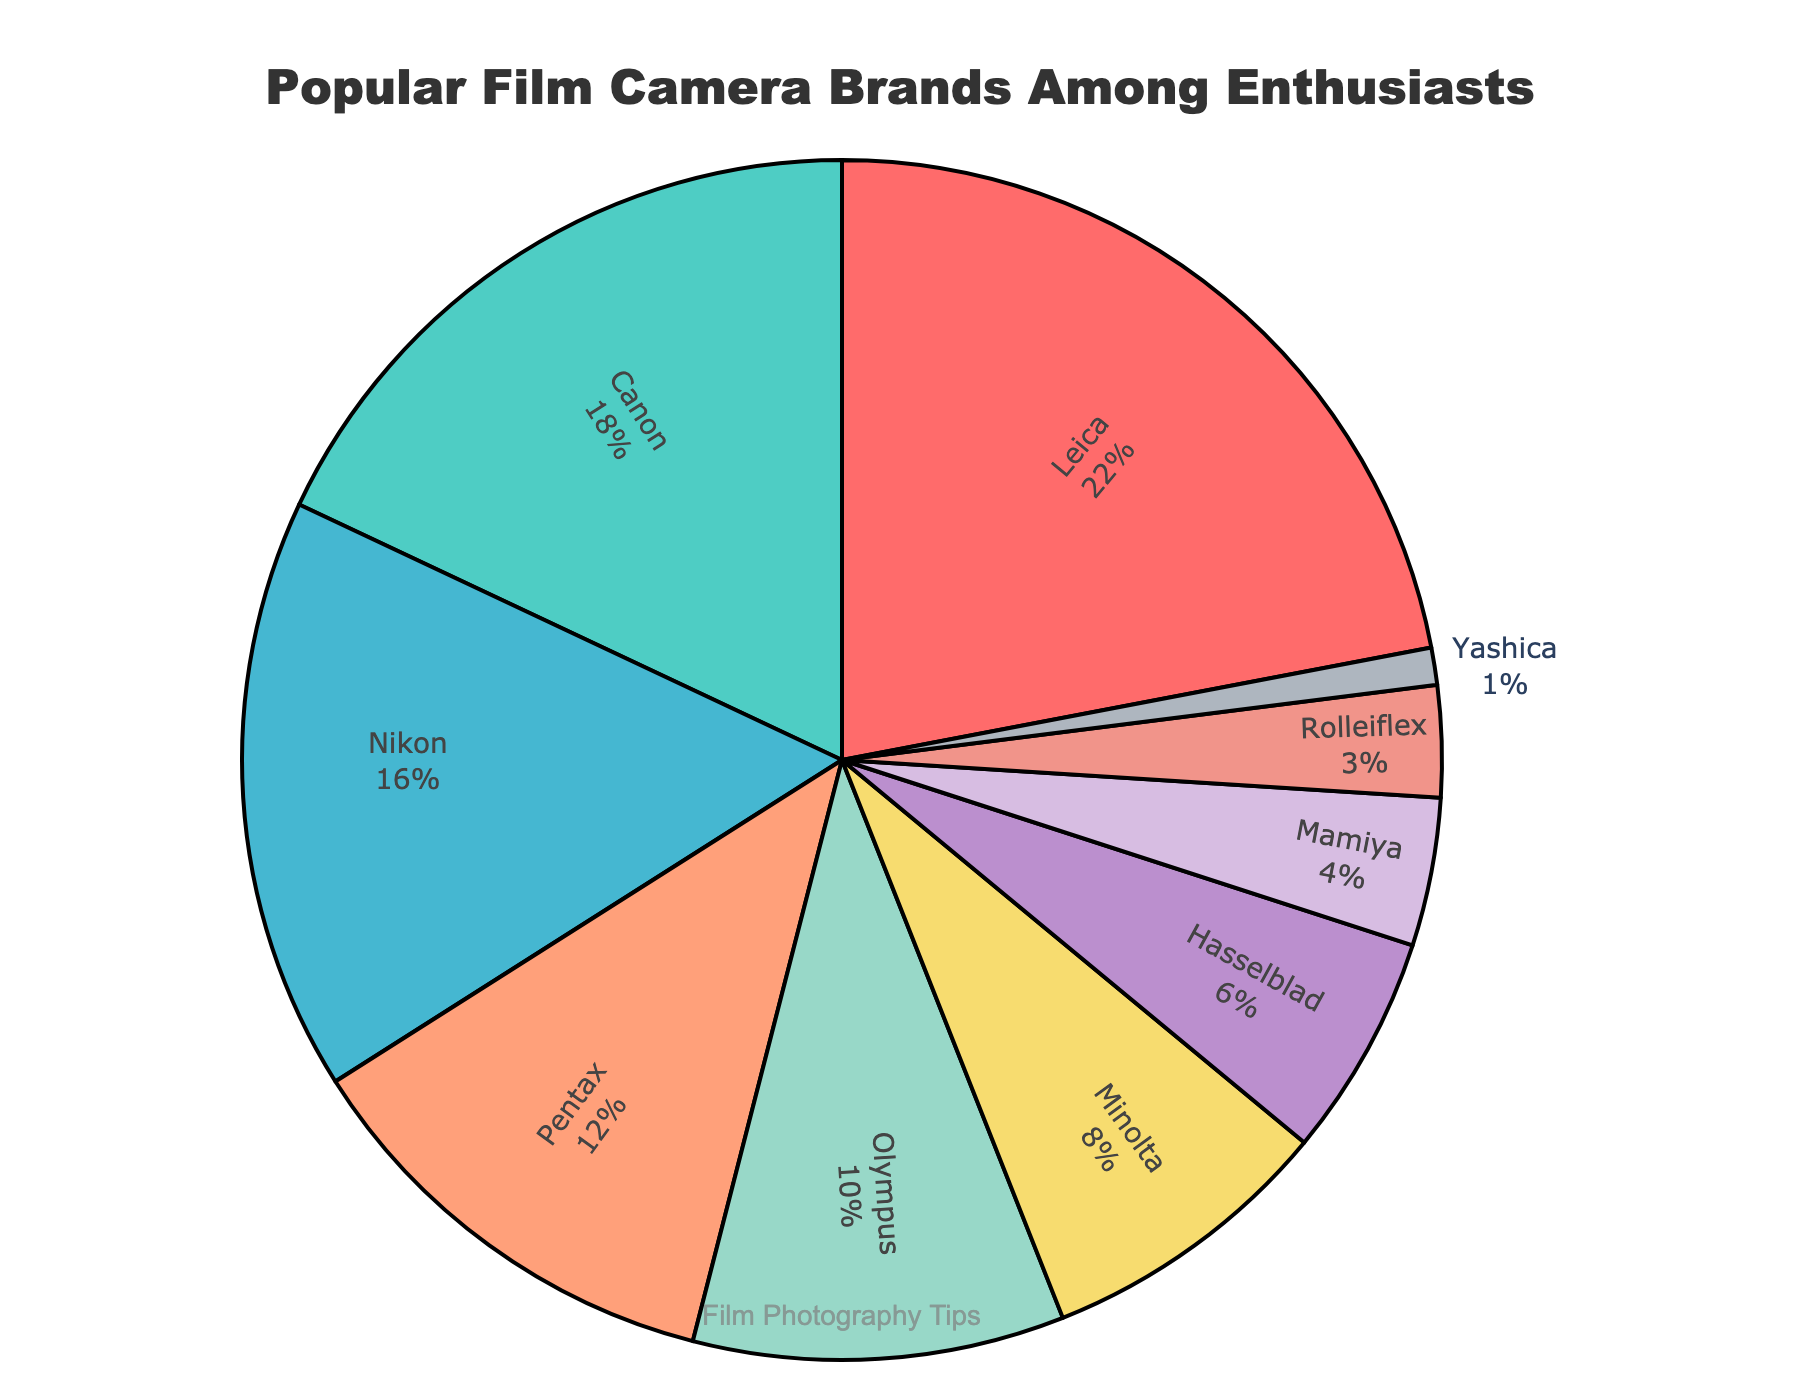Which brand has the highest percentage among film camera enthusiasts? The figure shows various brands with their respective percentage values. Leica has the highest percentage of 22%.
Answer: Leica Which brand has the lowest percentage among film camera enthusiasts? The figure displays all the brands with their percentages. Yashica has the lowest at 1%.
Answer: Yashica What is the combined percentage of Canon and Nikon enthusiasts? Canon has 18% and Nikon has 16%. Adding these together: 18% + 16% = 34%.
Answer: 34% How does the percentage of Olympus compare to that of Pentax? The figure shows Olympus at 10% and Pentax at 12%. Olympus's percentage is 2% less than Pentax's.
Answer: 2% less What is the total percentage of the four least popular brands? The four least popular brands are Rolleiflex (3%), Mamiya (4%), Hasselblad (6%), and Yashica (1%). Summing these: 3% + 4% + 6% + 1% = 14%.
Answer: 14% Which brand is represented by the color red in the pie chart? The figure shows a custom color palette, where Leica is represented by the color red.
Answer: Leica Which two brands combined make up 28% of the pie chart? According to the figure, Pentax is 12% and Olympus is 10%. Adding Minolta's 8%: 12% + 10% + 8% = 30%. The other option is Canon (18%) and Nikon (16%), which is too high. Thus, no exact match in the given brand percentages equals 28%.
Answer: None If Pentax and Minolta's percentages were combined, which brand(s) would have a lower percentage than their total combined percentage? Pentax is at 12% and Minolta is at 8%, making their combined percentage 20%. Brands with percentages lower than 20% are all other brands except Leica.
Answer: Canon, Nikon, Olympus, Minolta, Hasselblad, Mamiya, Rolleiflex, Yashica What is the percentage difference between the most popular and least popular brands? The most popular brand is Leica at 22% and the least is Yashica at 1%. The difference is 22% - 1% = 21%.
Answer: 21% What is the percentage contribution of brands other than the top three (Leica, Canon, Nikon)? The top three brands are Leica (22%), Canon (18%), and Nikon (16%). Their combined percentage is 22% + 18% + 16% = 56%. Subtracting this from 100%: 100% - 56% = 44%.
Answer: 44% 